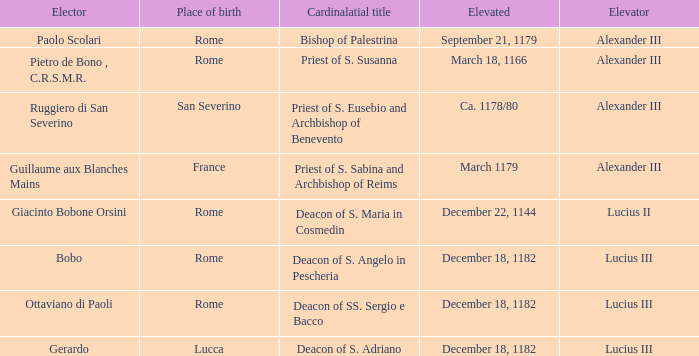What is the Elevator of the Elected Elevated on September 21, 1179? Alexander III. 